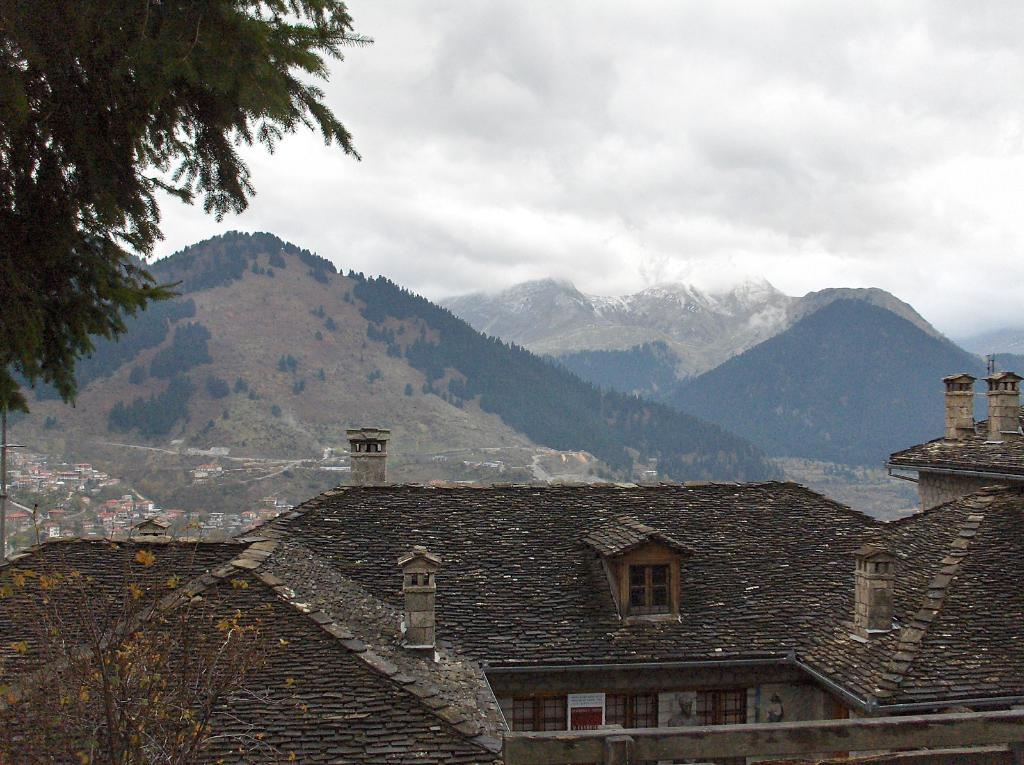What type of house is the main focus of the image? There is a big beautiful house in the image. Are there any other houses visible in the image? Yes, there are many small houses in the distance behind the big house. What can be seen in the background of the image? Mountains and the sky are visible in the background of the image. How many calculators can be seen on the roof of the big house in the image? There are no calculators visible on the roof of the big house in the image. What type of drink is being served in the image? There is no drink visible in the image. 